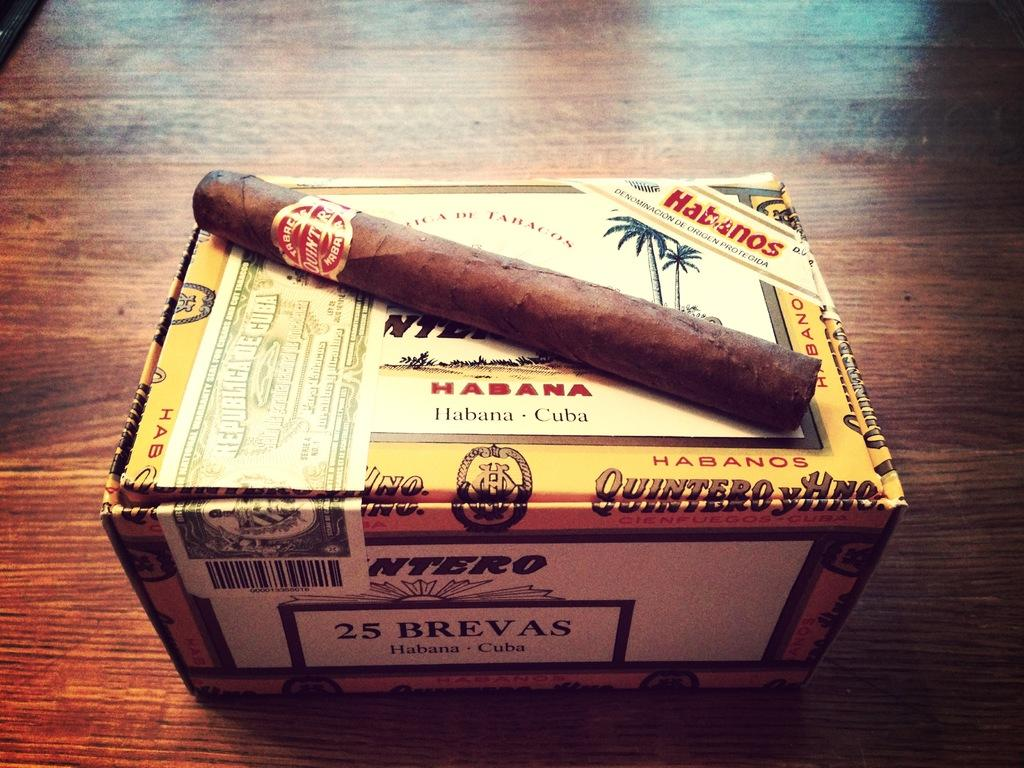<image>
Give a short and clear explanation of the subsequent image. A box of Cuban cigars in a yellow box. 